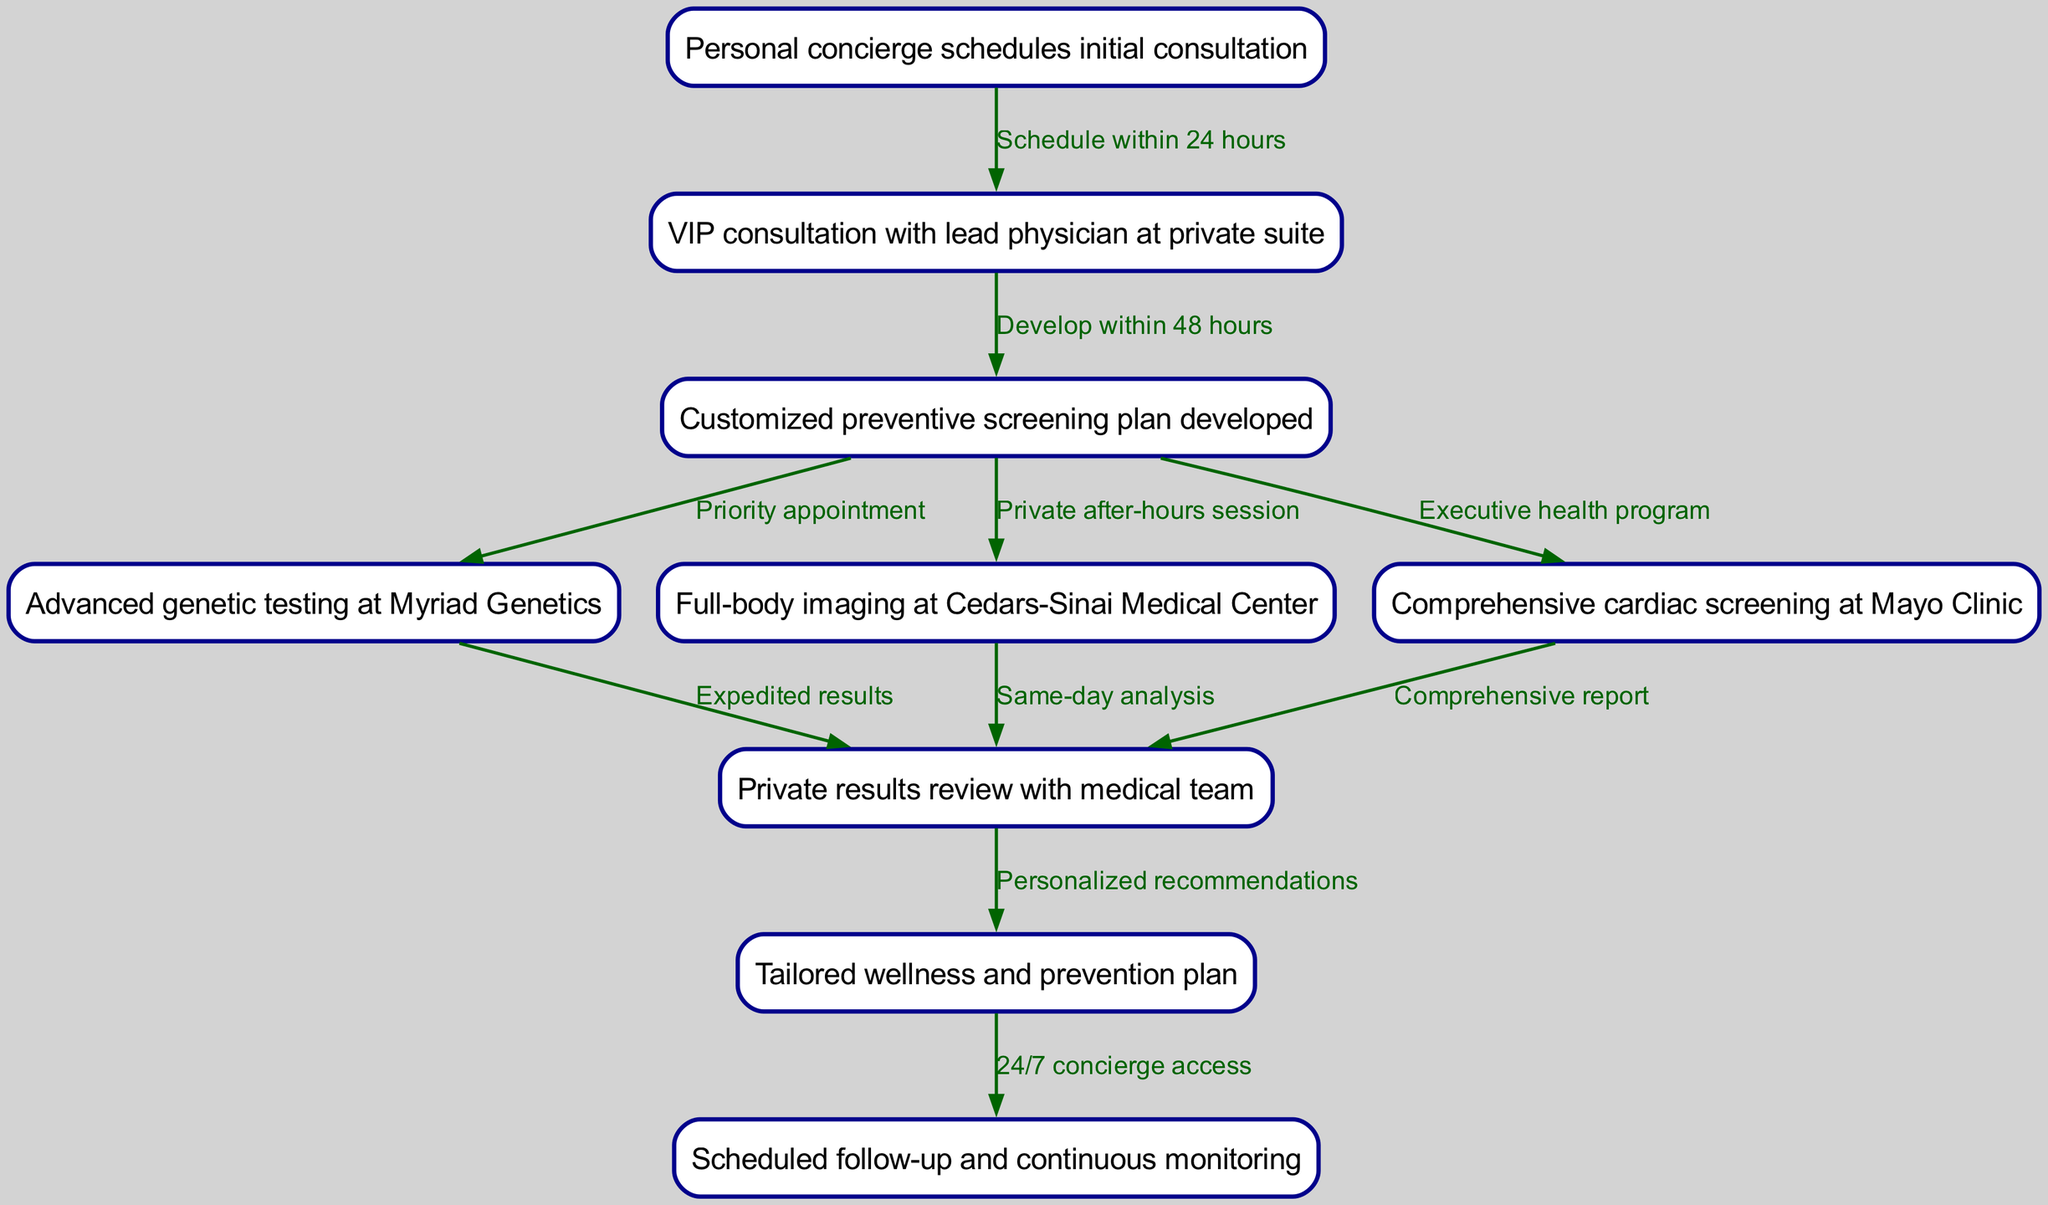What is the first step in the patient journey? The diagram indicates that the first step is the "Personal concierge schedules initial consultation." This is the initial contact that starts the patient journey.
Answer: Personal concierge schedules initial consultation How many nodes are present in the diagram? By counting the distinct elements labeled in the diagram, we find there are 9 nodes representing different parts of the patient journey.
Answer: 9 What is developed after the VIP consultation? Following the VIP consultation, the diagram shows that a "Customized preventive screening plan" is developed within 48 hours.
Answer: Customized preventive screening plan developed What is the relationship between genetic testing and results review? The diagram shows that after "Advanced genetic testing at Myriad Genetics," there is a flow to "Private results review with medical team," indicating genetic testing leads directly to the results review.
Answer: Expedited results What happens if the personalized plan includes imaging? If the personalized plan includes imaging, it leads to "Full-body imaging at Cedars-Sinai Medical Center," which then flows to "Private results review with medical team" through "Same-day analysis" as per the diagram's path.
Answer: Same-day analysis What provides tailored next steps after results review? The diagram indicates that after the "Private results review with medical team," the next step is to create a "Tailored wellness and prevention plan," which includes personalized recommendations based on the results.
Answer: Tailored wellness and prevention plan How is the follow-up accessed after the wellness plan? According to the diagram, access to follow-up is granted through "24/7 concierge access" provided after the "Tailored wellness and prevention plan" is established, ensuring continuous support for the patient.
Answer: 24/7 concierge access Which institution conducts the cardiac screening? The diagram specifically notes that the comprehensive cardiac screening takes place at the "Mayo Clinic," as indicated in the flow of the patient journey.
Answer: Mayo Clinic What type of appointment is prioritized after the personalized plan? Following the personalized plan, "Advanced genetic testing at Myriad Genetics" is set as a priority appointment according to the flow of the diagram, ensuring early testing.
Answer: Priority appointment 